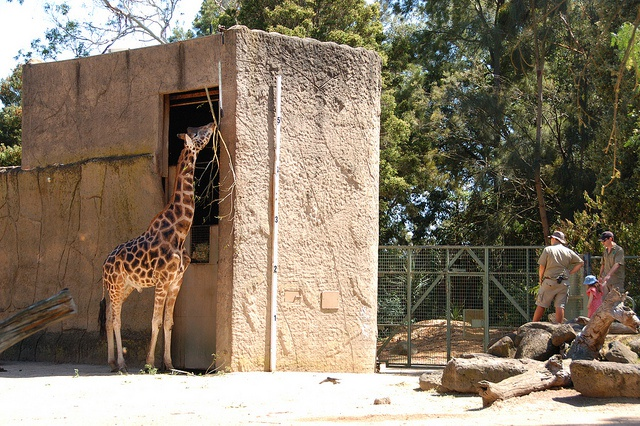Describe the objects in this image and their specific colors. I can see giraffe in ivory, maroon, black, gray, and tan tones, people in ivory, gray, and white tones, people in ivory, gray, brown, and maroon tones, and people in ivory, brown, and maroon tones in this image. 